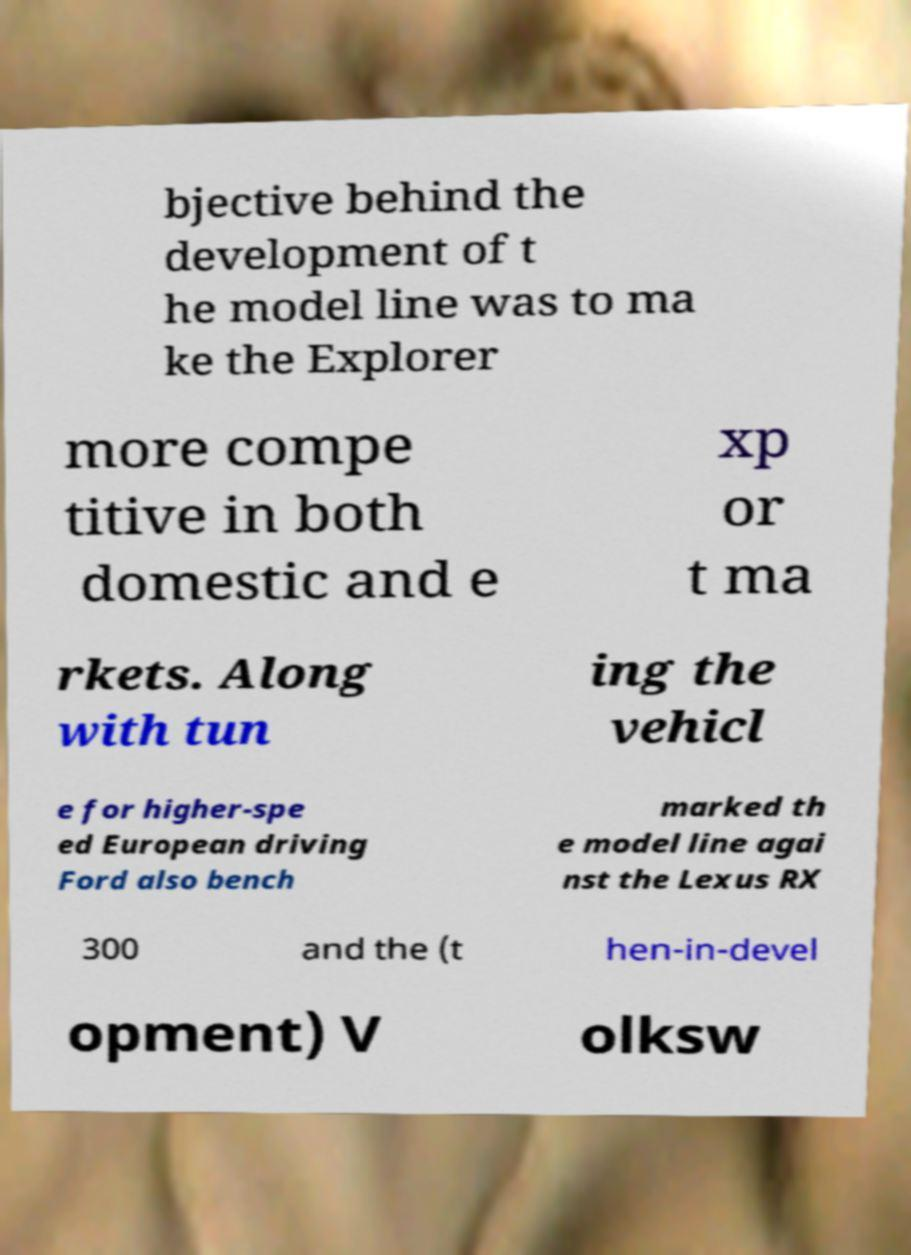Please read and relay the text visible in this image. What does it say? bjective behind the development of t he model line was to ma ke the Explorer more compe titive in both domestic and e xp or t ma rkets. Along with tun ing the vehicl e for higher-spe ed European driving Ford also bench marked th e model line agai nst the Lexus RX 300 and the (t hen-in-devel opment) V olksw 